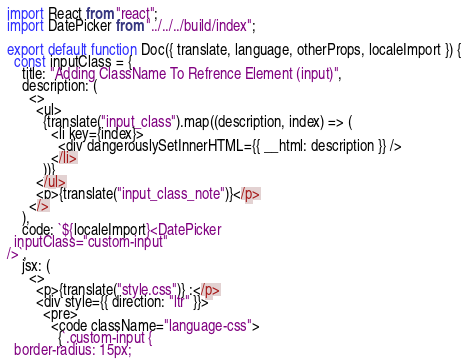Convert code to text. <code><loc_0><loc_0><loc_500><loc_500><_JavaScript_>import React from "react";
import DatePicker from "../../../build/index";

export default function Doc({ translate, language, otherProps, localeImport }) {
  const inputClass = {
    title: "Adding ClassName To Refrence Element (input)",
    description: (
      <>
        <ul>
          {translate("input_class").map((description, index) => (
            <li key={index}>
              <div dangerouslySetInnerHTML={{ __html: description }} />
            </li>
          ))}
        </ul>
        <p>{translate("input_class_note")}</p>
      </>
    ),
    code: `${localeImport}<DatePicker
  inputClass="custom-input"
/>`,
    jsx: (
      <>
        <p>{translate("style.css")} :</p>
        <div style={{ direction: "ltr" }}>
          <pre>
            <code className="language-css">
              {`.custom-input {
  border-radius: 15px;</code> 